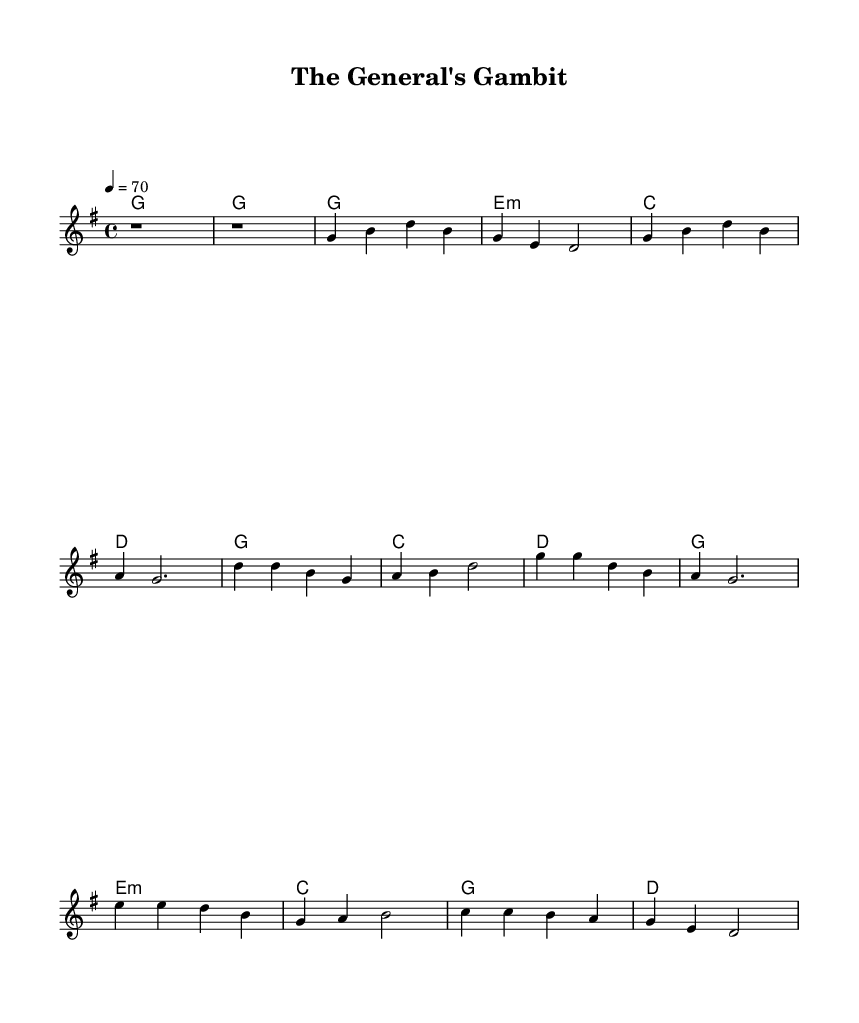what is the key signature of this music? The key signature is identified by the sharps or flats indicated at the beginning of the staff. In this case, there are no sharps or flats, indicating a G major key signature.
Answer: G major what is the time signature of this music? The time signature is located at the beginning of the score, indicated by the numbers that follow the clef. Here, it is marked as 4/4, meaning there are four beats in each measure and the quarter note gets one beat.
Answer: 4/4 what is the tempo marking for this music? The tempo marking is shown at the beginning of the score as a number, indicating how many beats per minute the music should be played. In this case, it is marked as "4 = 70," signifying that the quarter note should be played at a speed of 70 beats per minute.
Answer: 70 how many verses are present in the song? By counting the sections clearly labeled in the score, there is one verse section labeled "Verse 1," and combined with the "Chorus" and "Bridge," it results in three distinct sections, but specifically, the question asks for the verse sections.
Answer: 1 which chord follows the first verse? By analyzing the harmony section immediately after the first verse's melody, it can be seen that it proceeds with an E minor chord as indicated in the harmonies section.
Answer: E minor what is the central theme reflected in the lyrics? The lyrics focus on the analogies between life and card games, suggesting decisions, strategy, and the unpredictability of life, reflecting a central theme of strategic decisions and their consequences.
Answer: Strategy what can be inferred about the mood of the song from the lyrics? The lyrics express a reflective and strategic approach to life's challenges, suggesting a mood of contemplation about choices and their outcomes. The mention of wisdom and learning from experiences indicates a serious yet hopeful tone.
Answer: Contemplative 